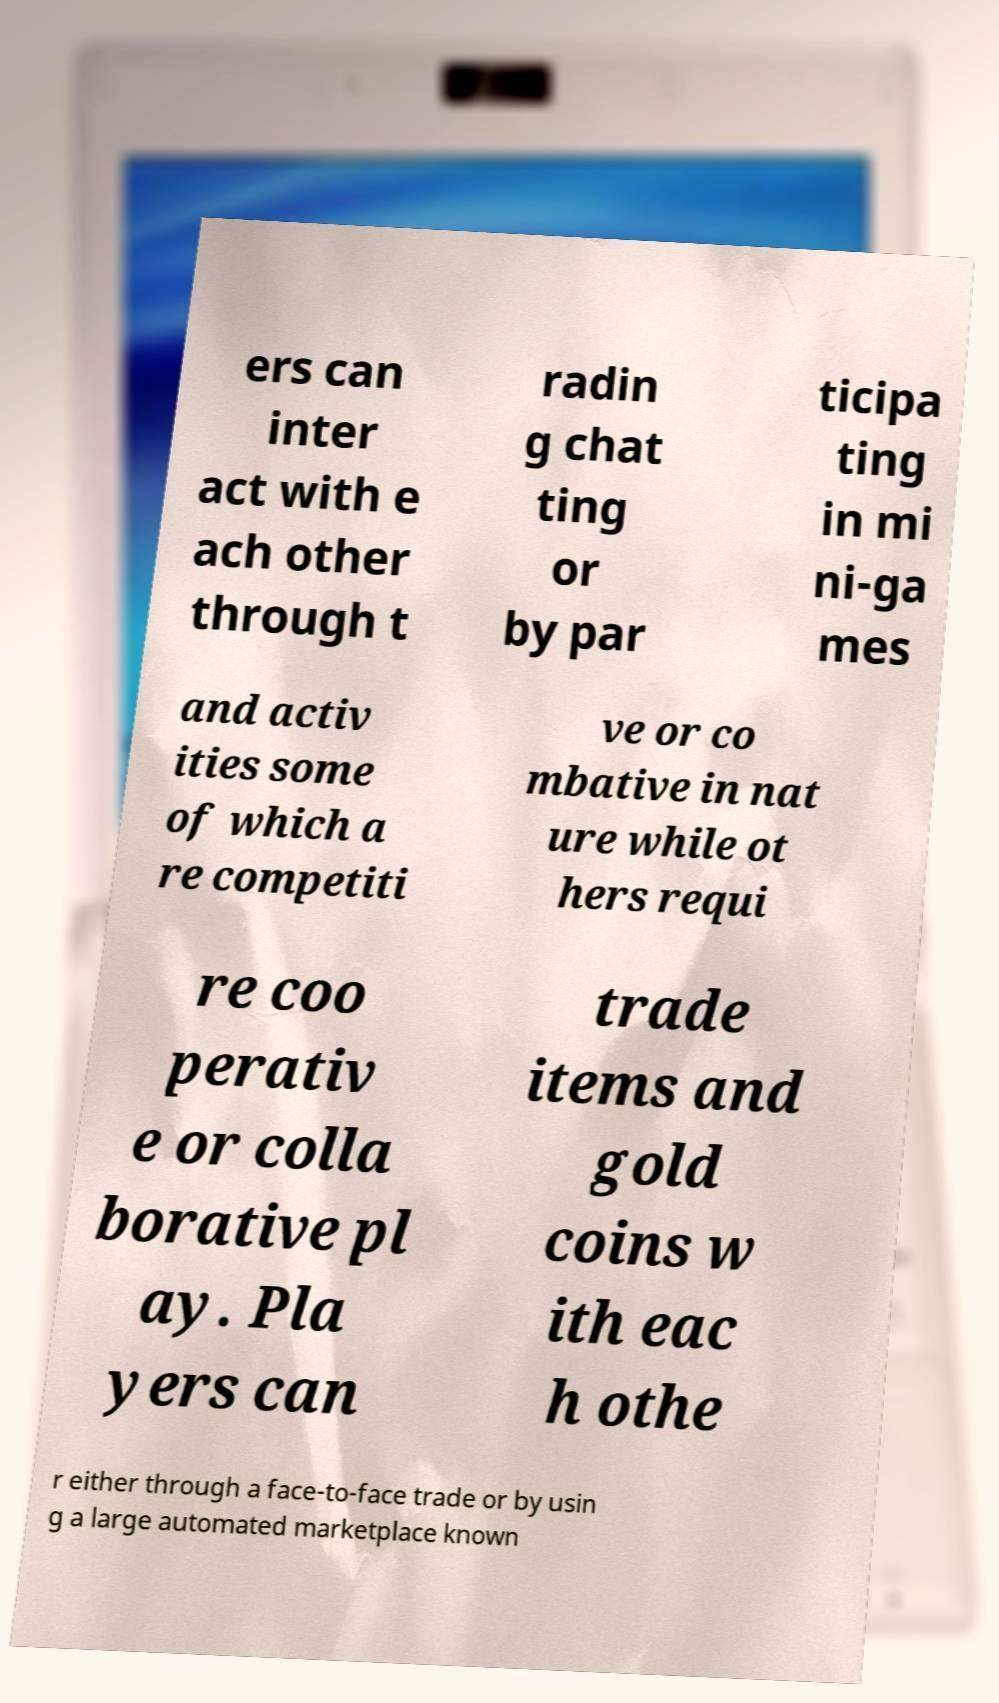Could you extract and type out the text from this image? ers can inter act with e ach other through t radin g chat ting or by par ticipa ting in mi ni-ga mes and activ ities some of which a re competiti ve or co mbative in nat ure while ot hers requi re coo perativ e or colla borative pl ay. Pla yers can trade items and gold coins w ith eac h othe r either through a face-to-face trade or by usin g a large automated marketplace known 